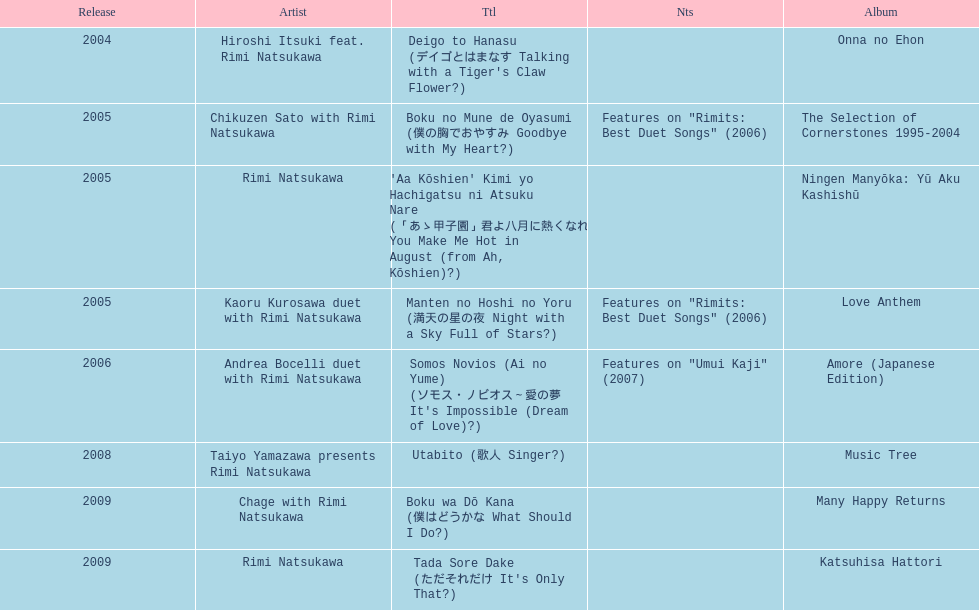How many titles have only one artist? 2. 